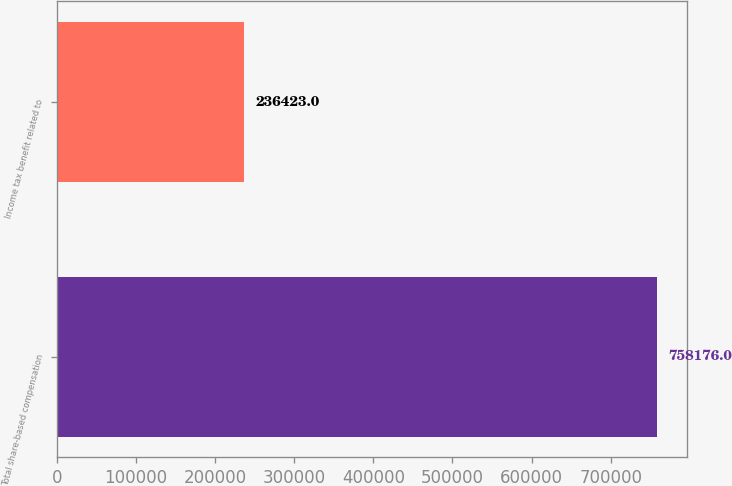<chart> <loc_0><loc_0><loc_500><loc_500><bar_chart><fcel>Total share-based compensation<fcel>Income tax benefit related to<nl><fcel>758176<fcel>236423<nl></chart> 